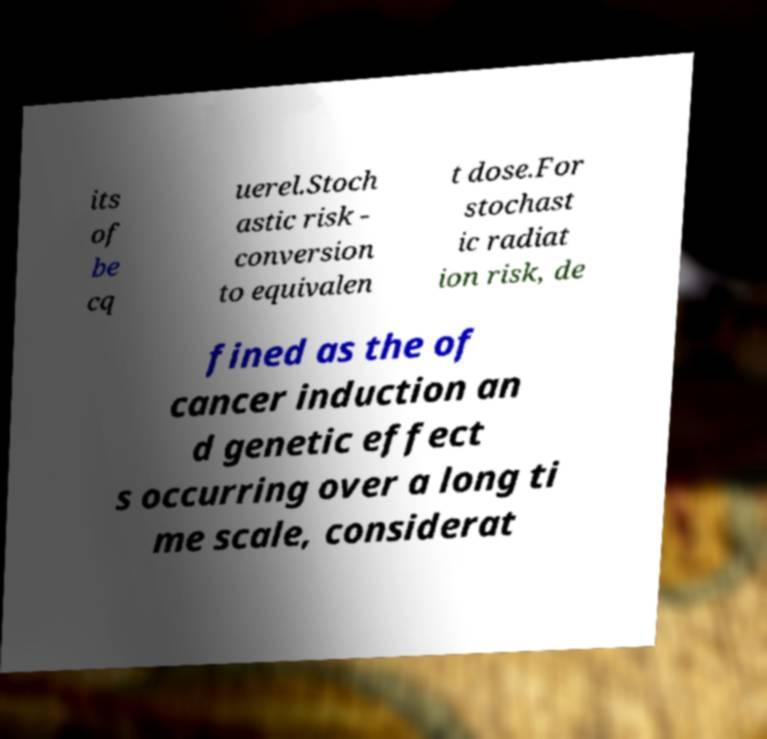Can you read and provide the text displayed in the image?This photo seems to have some interesting text. Can you extract and type it out for me? its of be cq uerel.Stoch astic risk - conversion to equivalen t dose.For stochast ic radiat ion risk, de fined as the of cancer induction an d genetic effect s occurring over a long ti me scale, considerat 